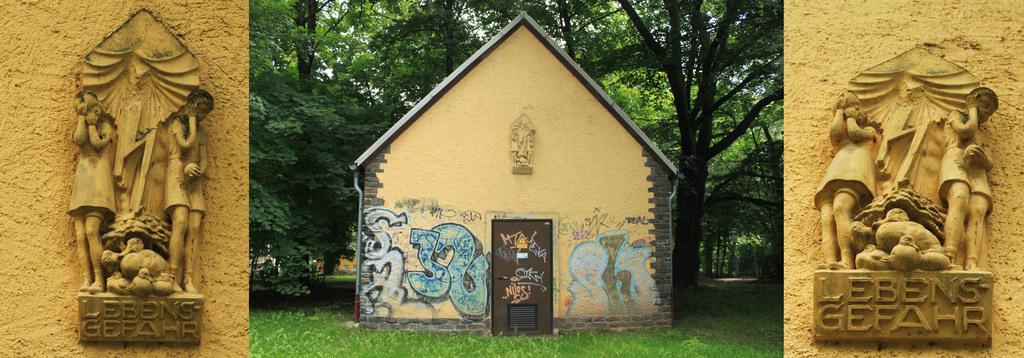What type of structure is visible in the image? There is a house in the image. What is in front of the house? There is grass in front of the house. What is behind the house? There are trees behind the house. What can be seen on the sides of the house? There are sculptures on both the left and right sides of the house. Can you hear the school bell ringing in the image? There is no school or bell present in the image, so it is not possible to hear a school bell ringing. 